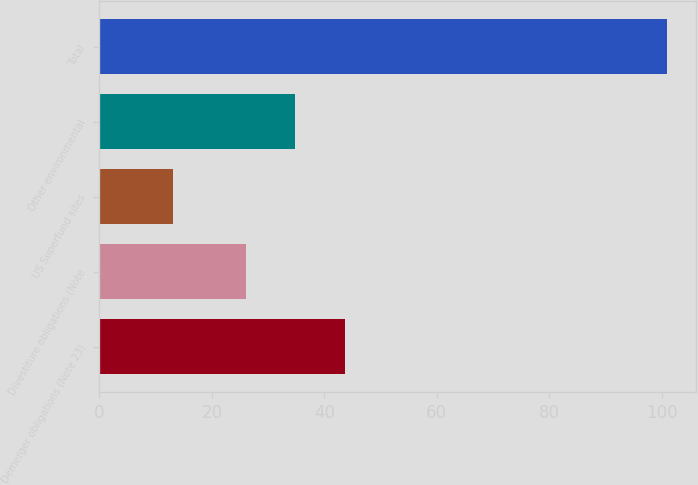Convert chart to OTSL. <chart><loc_0><loc_0><loc_500><loc_500><bar_chart><fcel>Demerger obligations (Note 23)<fcel>Divestiture obligations (Note<fcel>US Superfund sites<fcel>Other environmental<fcel>Total<nl><fcel>43.6<fcel>26<fcel>13<fcel>34.8<fcel>101<nl></chart> 